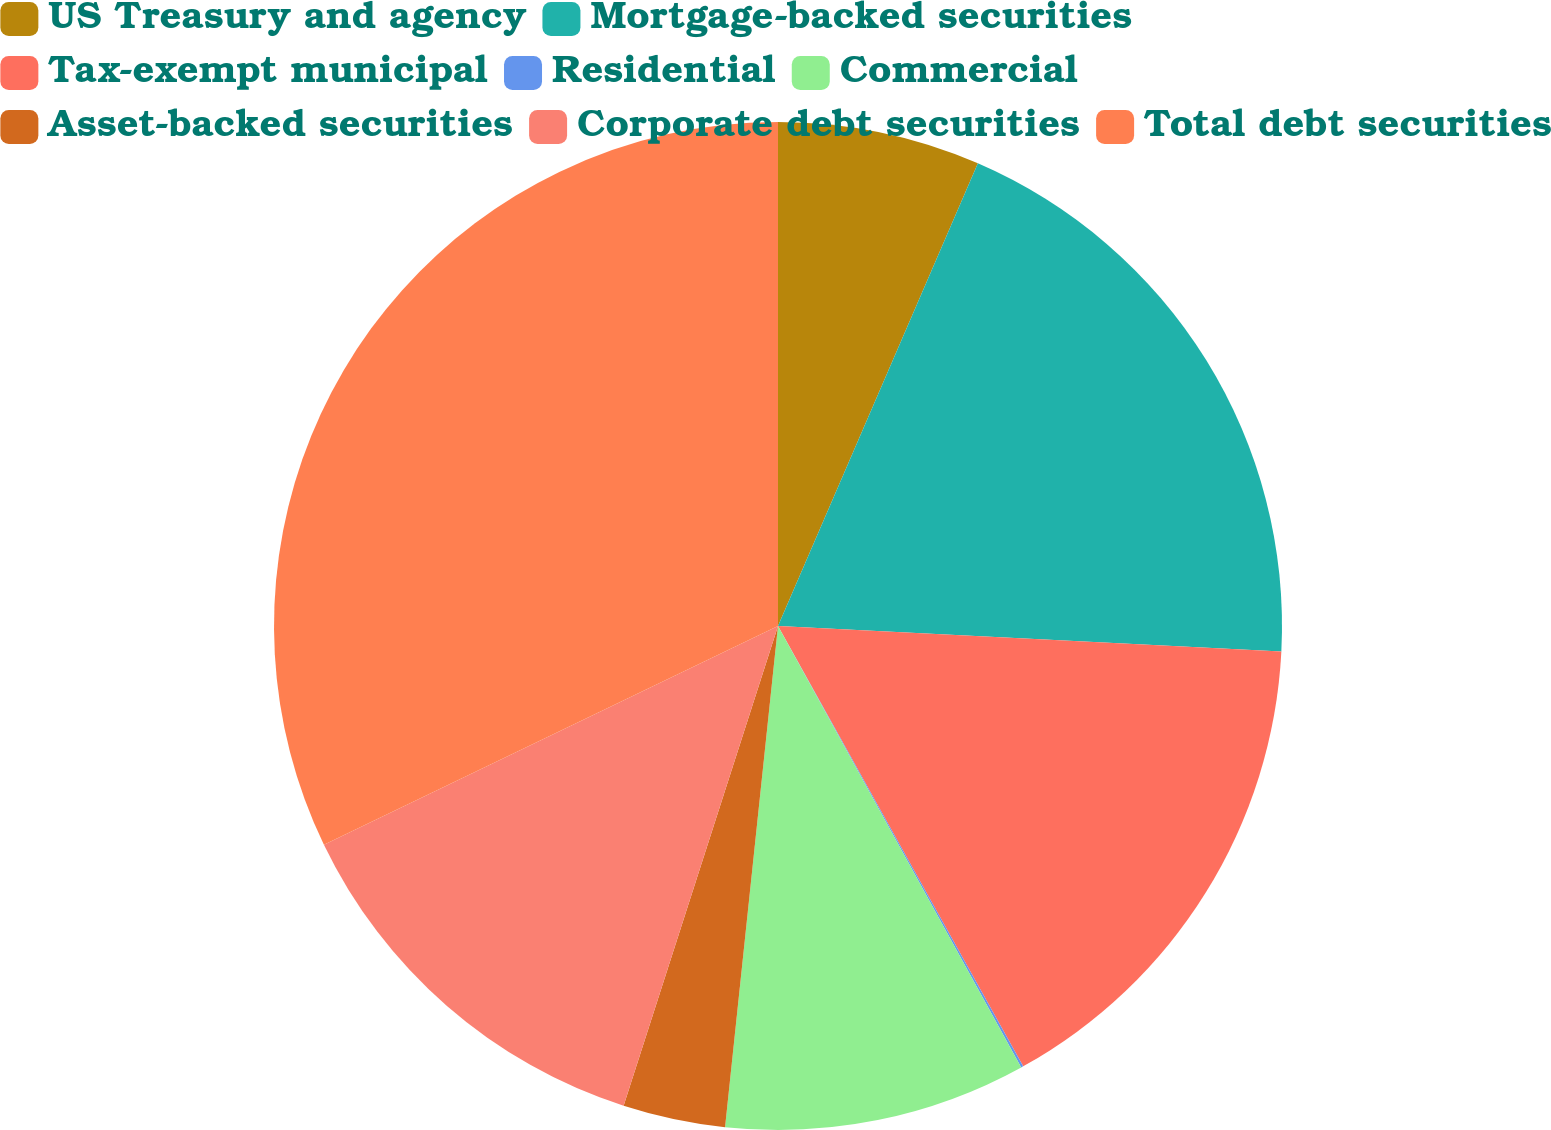Convert chart. <chart><loc_0><loc_0><loc_500><loc_500><pie_chart><fcel>US Treasury and agency<fcel>Mortgage-backed securities<fcel>Tax-exempt municipal<fcel>Residential<fcel>Commercial<fcel>Asset-backed securities<fcel>Corporate debt securities<fcel>Total debt securities<nl><fcel>6.49%<fcel>19.31%<fcel>16.11%<fcel>0.07%<fcel>9.69%<fcel>3.28%<fcel>12.9%<fcel>32.14%<nl></chart> 